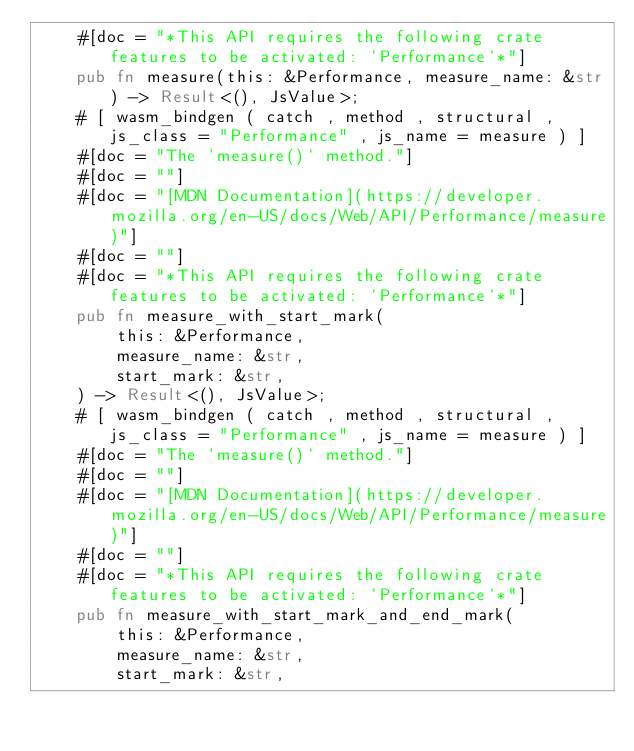Convert code to text. <code><loc_0><loc_0><loc_500><loc_500><_Rust_>    #[doc = "*This API requires the following crate features to be activated: `Performance`*"]
    pub fn measure(this: &Performance, measure_name: &str) -> Result<(), JsValue>;
    # [ wasm_bindgen ( catch , method , structural , js_class = "Performance" , js_name = measure ) ]
    #[doc = "The `measure()` method."]
    #[doc = ""]
    #[doc = "[MDN Documentation](https://developer.mozilla.org/en-US/docs/Web/API/Performance/measure)"]
    #[doc = ""]
    #[doc = "*This API requires the following crate features to be activated: `Performance`*"]
    pub fn measure_with_start_mark(
        this: &Performance,
        measure_name: &str,
        start_mark: &str,
    ) -> Result<(), JsValue>;
    # [ wasm_bindgen ( catch , method , structural , js_class = "Performance" , js_name = measure ) ]
    #[doc = "The `measure()` method."]
    #[doc = ""]
    #[doc = "[MDN Documentation](https://developer.mozilla.org/en-US/docs/Web/API/Performance/measure)"]
    #[doc = ""]
    #[doc = "*This API requires the following crate features to be activated: `Performance`*"]
    pub fn measure_with_start_mark_and_end_mark(
        this: &Performance,
        measure_name: &str,
        start_mark: &str,</code> 